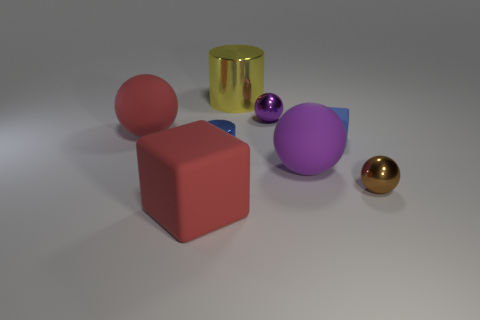Is the tiny rubber thing the same color as the small cylinder?
Make the answer very short. Yes. Does the object behind the tiny purple shiny ball have the same material as the block that is in front of the tiny brown thing?
Keep it short and to the point. No. What color is the other metal thing that is the same shape as the tiny blue metal thing?
Ensure brevity in your answer.  Yellow. The big cylinder that is behind the cube that is right of the small purple ball is made of what material?
Ensure brevity in your answer.  Metal. There is a tiny shiny object that is left of the big yellow object; is its shape the same as the tiny metallic thing that is in front of the big purple rubber object?
Provide a succinct answer. No. What size is the rubber object that is on the left side of the purple matte sphere and behind the tiny brown metallic ball?
Make the answer very short. Large. How many other things are there of the same color as the big shiny cylinder?
Offer a very short reply. 0. Is the thing that is in front of the tiny brown object made of the same material as the red ball?
Provide a succinct answer. Yes. Is there any other thing that has the same size as the yellow thing?
Your answer should be compact. Yes. Is the number of big purple rubber objects that are behind the large purple object less than the number of red things that are in front of the large red rubber sphere?
Provide a short and direct response. Yes. 